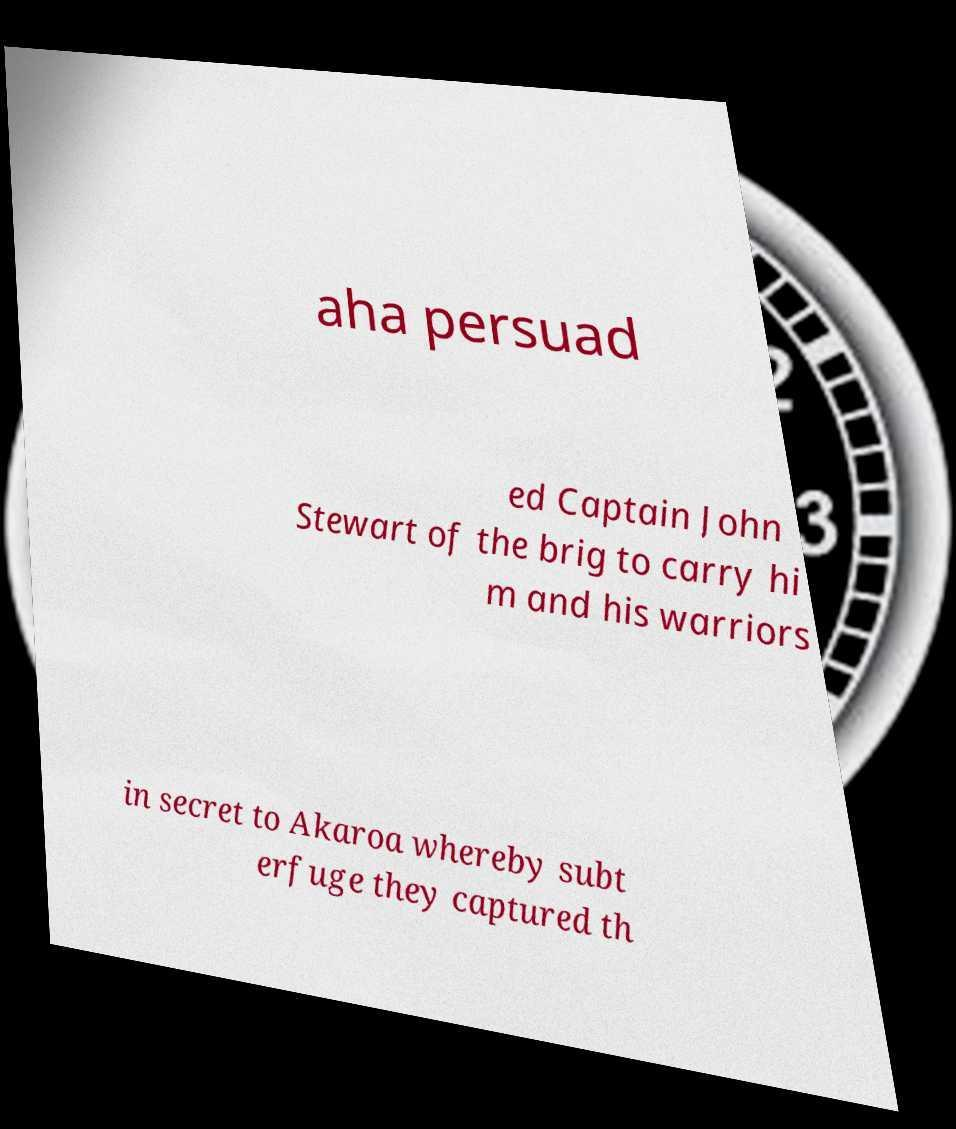What messages or text are displayed in this image? I need them in a readable, typed format. aha persuad ed Captain John Stewart of the brig to carry hi m and his warriors in secret to Akaroa whereby subt erfuge they captured th 